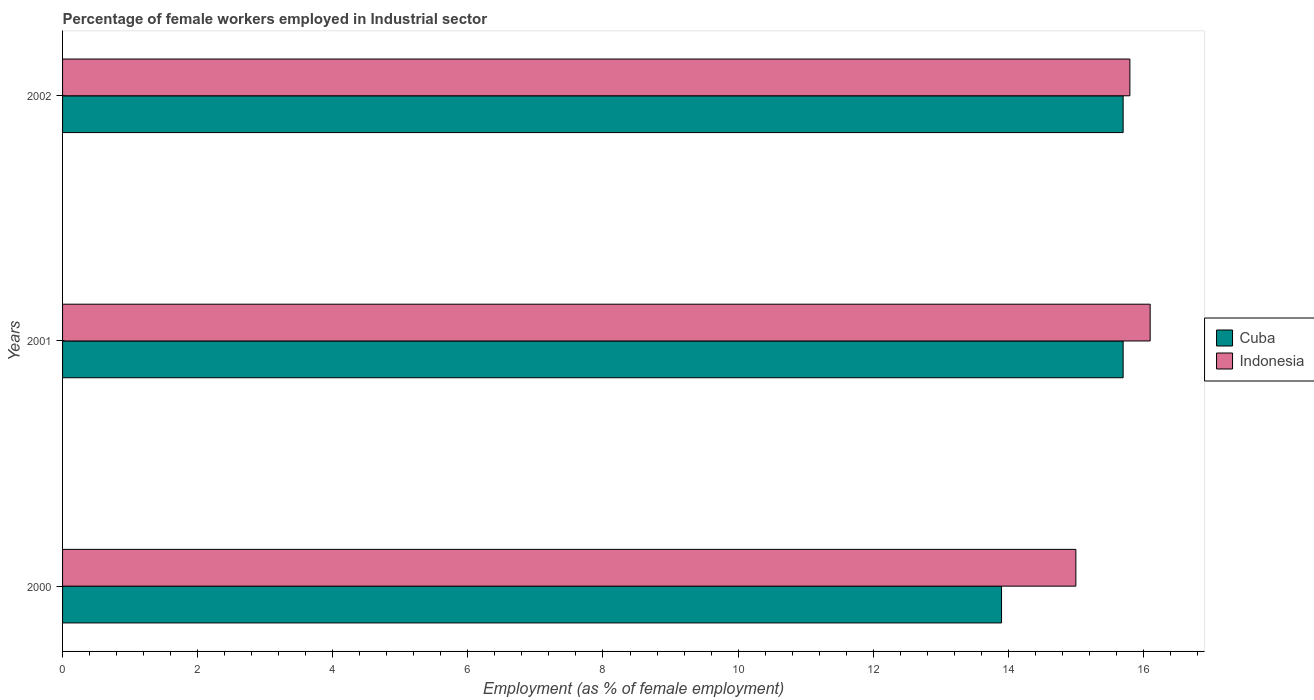Are the number of bars on each tick of the Y-axis equal?
Your answer should be compact. Yes. How many bars are there on the 2nd tick from the top?
Offer a terse response. 2. How many bars are there on the 2nd tick from the bottom?
Provide a short and direct response. 2. What is the label of the 2nd group of bars from the top?
Provide a short and direct response. 2001. In how many cases, is the number of bars for a given year not equal to the number of legend labels?
Ensure brevity in your answer.  0. What is the percentage of females employed in Industrial sector in Cuba in 2001?
Provide a short and direct response. 15.7. Across all years, what is the maximum percentage of females employed in Industrial sector in Indonesia?
Provide a short and direct response. 16.1. Across all years, what is the minimum percentage of females employed in Industrial sector in Cuba?
Offer a very short reply. 13.9. In which year was the percentage of females employed in Industrial sector in Cuba maximum?
Ensure brevity in your answer.  2001. What is the total percentage of females employed in Industrial sector in Indonesia in the graph?
Provide a short and direct response. 46.9. What is the difference between the percentage of females employed in Industrial sector in Indonesia in 2001 and the percentage of females employed in Industrial sector in Cuba in 2002?
Keep it short and to the point. 0.4. What is the average percentage of females employed in Industrial sector in Cuba per year?
Give a very brief answer. 15.1. In the year 2002, what is the difference between the percentage of females employed in Industrial sector in Indonesia and percentage of females employed in Industrial sector in Cuba?
Provide a succinct answer. 0.1. In how many years, is the percentage of females employed in Industrial sector in Cuba greater than 3.6 %?
Provide a succinct answer. 3. What is the ratio of the percentage of females employed in Industrial sector in Cuba in 2000 to that in 2002?
Offer a terse response. 0.89. Is the percentage of females employed in Industrial sector in Cuba in 2000 less than that in 2001?
Give a very brief answer. Yes. Is the difference between the percentage of females employed in Industrial sector in Indonesia in 2000 and 2001 greater than the difference between the percentage of females employed in Industrial sector in Cuba in 2000 and 2001?
Provide a short and direct response. Yes. What is the difference between the highest and the lowest percentage of females employed in Industrial sector in Cuba?
Make the answer very short. 1.8. In how many years, is the percentage of females employed in Industrial sector in Cuba greater than the average percentage of females employed in Industrial sector in Cuba taken over all years?
Offer a terse response. 2. What does the 2nd bar from the top in 2002 represents?
Your answer should be compact. Cuba. What is the title of the graph?
Keep it short and to the point. Percentage of female workers employed in Industrial sector. What is the label or title of the X-axis?
Your response must be concise. Employment (as % of female employment). What is the label or title of the Y-axis?
Your answer should be very brief. Years. What is the Employment (as % of female employment) of Cuba in 2000?
Keep it short and to the point. 13.9. What is the Employment (as % of female employment) in Indonesia in 2000?
Offer a very short reply. 15. What is the Employment (as % of female employment) in Cuba in 2001?
Provide a succinct answer. 15.7. What is the Employment (as % of female employment) of Indonesia in 2001?
Your response must be concise. 16.1. What is the Employment (as % of female employment) of Cuba in 2002?
Offer a terse response. 15.7. What is the Employment (as % of female employment) in Indonesia in 2002?
Provide a short and direct response. 15.8. Across all years, what is the maximum Employment (as % of female employment) in Cuba?
Ensure brevity in your answer.  15.7. Across all years, what is the maximum Employment (as % of female employment) of Indonesia?
Your response must be concise. 16.1. Across all years, what is the minimum Employment (as % of female employment) in Cuba?
Offer a terse response. 13.9. What is the total Employment (as % of female employment) in Cuba in the graph?
Ensure brevity in your answer.  45.3. What is the total Employment (as % of female employment) of Indonesia in the graph?
Your answer should be very brief. 46.9. What is the difference between the Employment (as % of female employment) of Indonesia in 2001 and that in 2002?
Keep it short and to the point. 0.3. What is the average Employment (as % of female employment) in Cuba per year?
Offer a very short reply. 15.1. What is the average Employment (as % of female employment) of Indonesia per year?
Provide a succinct answer. 15.63. In the year 2002, what is the difference between the Employment (as % of female employment) in Cuba and Employment (as % of female employment) in Indonesia?
Make the answer very short. -0.1. What is the ratio of the Employment (as % of female employment) of Cuba in 2000 to that in 2001?
Your answer should be very brief. 0.89. What is the ratio of the Employment (as % of female employment) in Indonesia in 2000 to that in 2001?
Offer a very short reply. 0.93. What is the ratio of the Employment (as % of female employment) in Cuba in 2000 to that in 2002?
Your response must be concise. 0.89. What is the ratio of the Employment (as % of female employment) of Indonesia in 2000 to that in 2002?
Make the answer very short. 0.95. What is the ratio of the Employment (as % of female employment) of Cuba in 2001 to that in 2002?
Offer a terse response. 1. What is the difference between the highest and the second highest Employment (as % of female employment) of Cuba?
Provide a succinct answer. 0. What is the difference between the highest and the second highest Employment (as % of female employment) in Indonesia?
Give a very brief answer. 0.3. What is the difference between the highest and the lowest Employment (as % of female employment) of Indonesia?
Your answer should be compact. 1.1. 